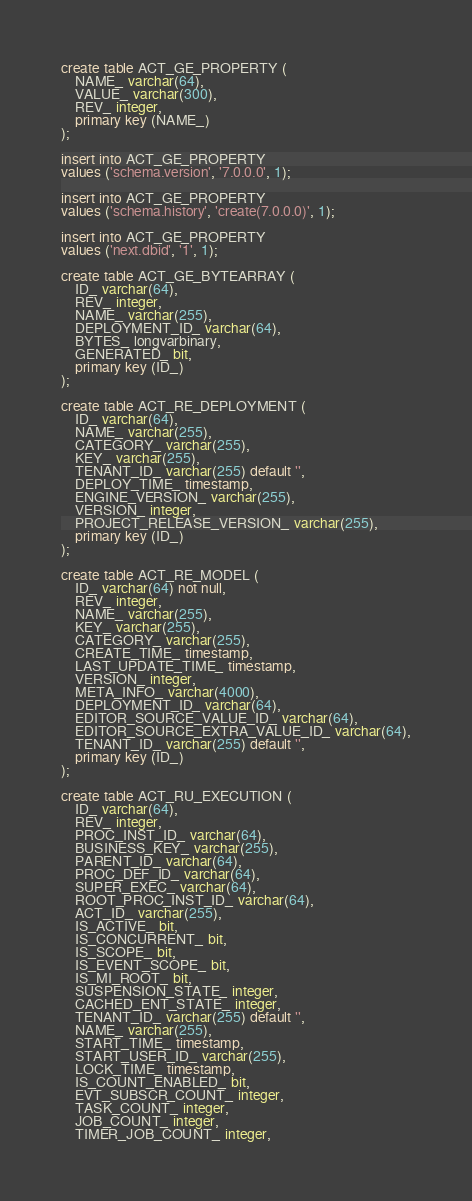Convert code to text. <code><loc_0><loc_0><loc_500><loc_500><_SQL_>create table ACT_GE_PROPERTY (
    NAME_ varchar(64),
    VALUE_ varchar(300),
    REV_ integer,
    primary key (NAME_)
);

insert into ACT_GE_PROPERTY
values ('schema.version', '7.0.0.0', 1);

insert into ACT_GE_PROPERTY
values ('schema.history', 'create(7.0.0.0)', 1);

insert into ACT_GE_PROPERTY
values ('next.dbid', '1', 1);

create table ACT_GE_BYTEARRAY (
    ID_ varchar(64),
    REV_ integer,
    NAME_ varchar(255),
    DEPLOYMENT_ID_ varchar(64),
    BYTES_ longvarbinary,
    GENERATED_ bit,
    primary key (ID_)
);

create table ACT_RE_DEPLOYMENT (
    ID_ varchar(64),
    NAME_ varchar(255),
    CATEGORY_ varchar(255),
    KEY_ varchar(255),
    TENANT_ID_ varchar(255) default '',
    DEPLOY_TIME_ timestamp,
    ENGINE_VERSION_ varchar(255),
    VERSION_ integer,
    PROJECT_RELEASE_VERSION_ varchar(255),
    primary key (ID_)
);

create table ACT_RE_MODEL (
    ID_ varchar(64) not null,
    REV_ integer,
    NAME_ varchar(255),
    KEY_ varchar(255),
    CATEGORY_ varchar(255),
    CREATE_TIME_ timestamp,
    LAST_UPDATE_TIME_ timestamp,
    VERSION_ integer,
    META_INFO_ varchar(4000),
    DEPLOYMENT_ID_ varchar(64),
    EDITOR_SOURCE_VALUE_ID_ varchar(64),
    EDITOR_SOURCE_EXTRA_VALUE_ID_ varchar(64),
    TENANT_ID_ varchar(255) default '',
    primary key (ID_)
);

create table ACT_RU_EXECUTION (
    ID_ varchar(64),
    REV_ integer,
    PROC_INST_ID_ varchar(64),
    BUSINESS_KEY_ varchar(255),
    PARENT_ID_ varchar(64),
    PROC_DEF_ID_ varchar(64),
    SUPER_EXEC_ varchar(64),
    ROOT_PROC_INST_ID_ varchar(64),
    ACT_ID_ varchar(255),
    IS_ACTIVE_ bit,
    IS_CONCURRENT_ bit,
    IS_SCOPE_ bit,
    IS_EVENT_SCOPE_ bit,
    IS_MI_ROOT_ bit,
    SUSPENSION_STATE_ integer,
    CACHED_ENT_STATE_ integer,
    TENANT_ID_ varchar(255) default '',
    NAME_ varchar(255),
    START_TIME_ timestamp,
    START_USER_ID_ varchar(255),
    LOCK_TIME_ timestamp,
    IS_COUNT_ENABLED_ bit,
    EVT_SUBSCR_COUNT_ integer, 
    TASK_COUNT_ integer, 
    JOB_COUNT_ integer, 
    TIMER_JOB_COUNT_ integer,</code> 